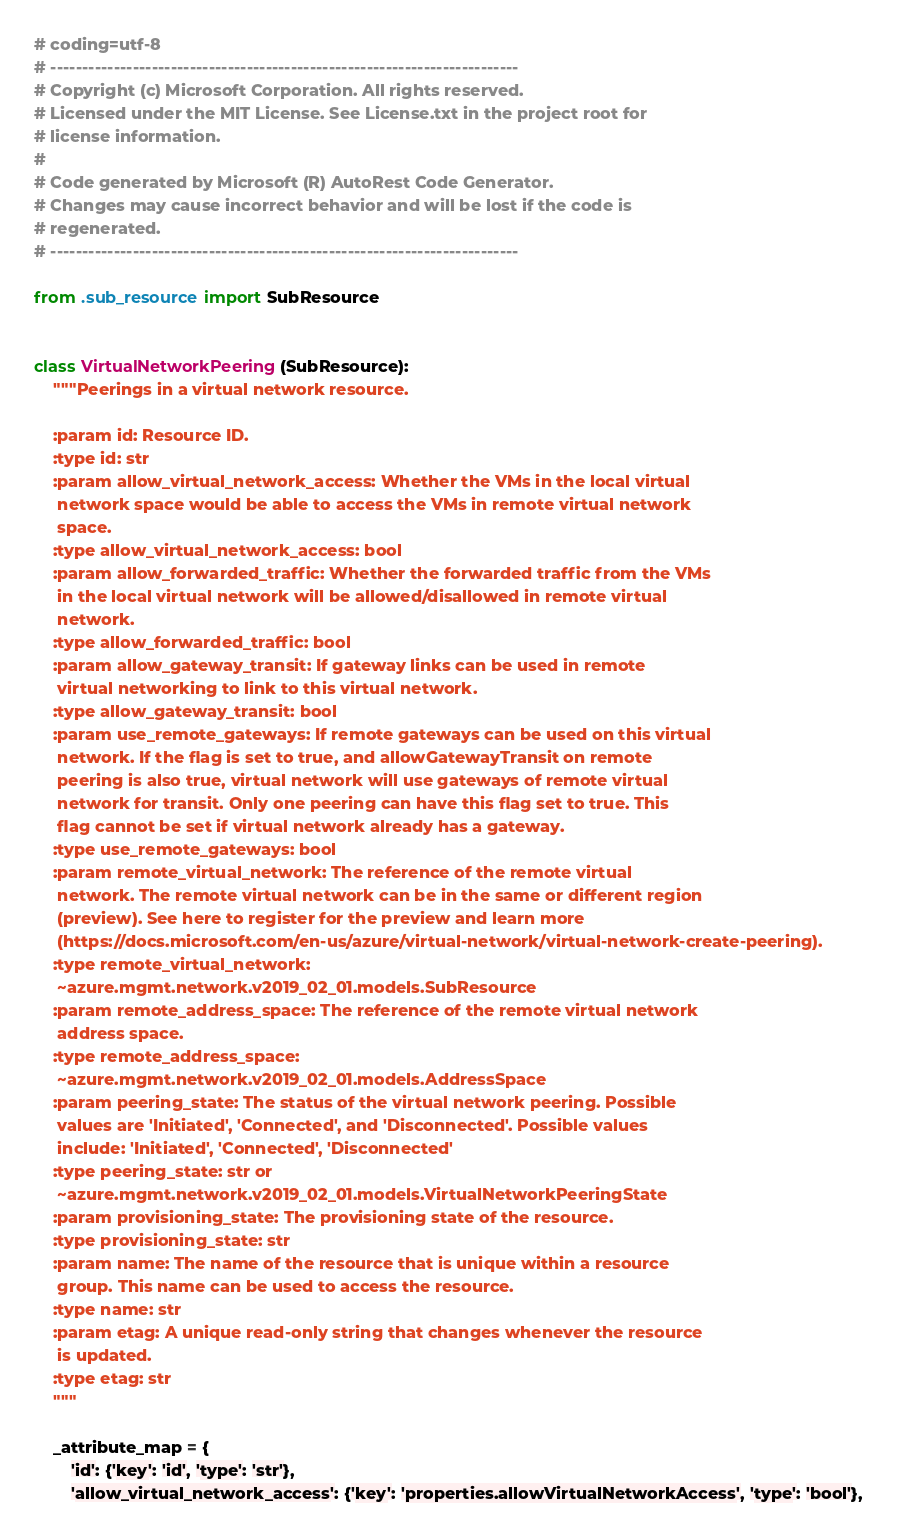<code> <loc_0><loc_0><loc_500><loc_500><_Python_># coding=utf-8
# --------------------------------------------------------------------------
# Copyright (c) Microsoft Corporation. All rights reserved.
# Licensed under the MIT License. See License.txt in the project root for
# license information.
#
# Code generated by Microsoft (R) AutoRest Code Generator.
# Changes may cause incorrect behavior and will be lost if the code is
# regenerated.
# --------------------------------------------------------------------------

from .sub_resource import SubResource


class VirtualNetworkPeering(SubResource):
    """Peerings in a virtual network resource.

    :param id: Resource ID.
    :type id: str
    :param allow_virtual_network_access: Whether the VMs in the local virtual
     network space would be able to access the VMs in remote virtual network
     space.
    :type allow_virtual_network_access: bool
    :param allow_forwarded_traffic: Whether the forwarded traffic from the VMs
     in the local virtual network will be allowed/disallowed in remote virtual
     network.
    :type allow_forwarded_traffic: bool
    :param allow_gateway_transit: If gateway links can be used in remote
     virtual networking to link to this virtual network.
    :type allow_gateway_transit: bool
    :param use_remote_gateways: If remote gateways can be used on this virtual
     network. If the flag is set to true, and allowGatewayTransit on remote
     peering is also true, virtual network will use gateways of remote virtual
     network for transit. Only one peering can have this flag set to true. This
     flag cannot be set if virtual network already has a gateway.
    :type use_remote_gateways: bool
    :param remote_virtual_network: The reference of the remote virtual
     network. The remote virtual network can be in the same or different region
     (preview). See here to register for the preview and learn more
     (https://docs.microsoft.com/en-us/azure/virtual-network/virtual-network-create-peering).
    :type remote_virtual_network:
     ~azure.mgmt.network.v2019_02_01.models.SubResource
    :param remote_address_space: The reference of the remote virtual network
     address space.
    :type remote_address_space:
     ~azure.mgmt.network.v2019_02_01.models.AddressSpace
    :param peering_state: The status of the virtual network peering. Possible
     values are 'Initiated', 'Connected', and 'Disconnected'. Possible values
     include: 'Initiated', 'Connected', 'Disconnected'
    :type peering_state: str or
     ~azure.mgmt.network.v2019_02_01.models.VirtualNetworkPeeringState
    :param provisioning_state: The provisioning state of the resource.
    :type provisioning_state: str
    :param name: The name of the resource that is unique within a resource
     group. This name can be used to access the resource.
    :type name: str
    :param etag: A unique read-only string that changes whenever the resource
     is updated.
    :type etag: str
    """

    _attribute_map = {
        'id': {'key': 'id', 'type': 'str'},
        'allow_virtual_network_access': {'key': 'properties.allowVirtualNetworkAccess', 'type': 'bool'},</code> 